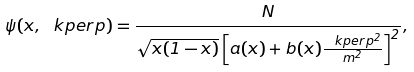<formula> <loc_0><loc_0><loc_500><loc_500>\psi ( x , \ k p e r p ) = \frac { N } { \sqrt { x ( 1 - x ) } \left [ a ( x ) + b ( x ) \frac { \ k p e r p ^ { 2 } } { m ^ { 2 } } \right ] ^ { 2 } } ,</formula> 